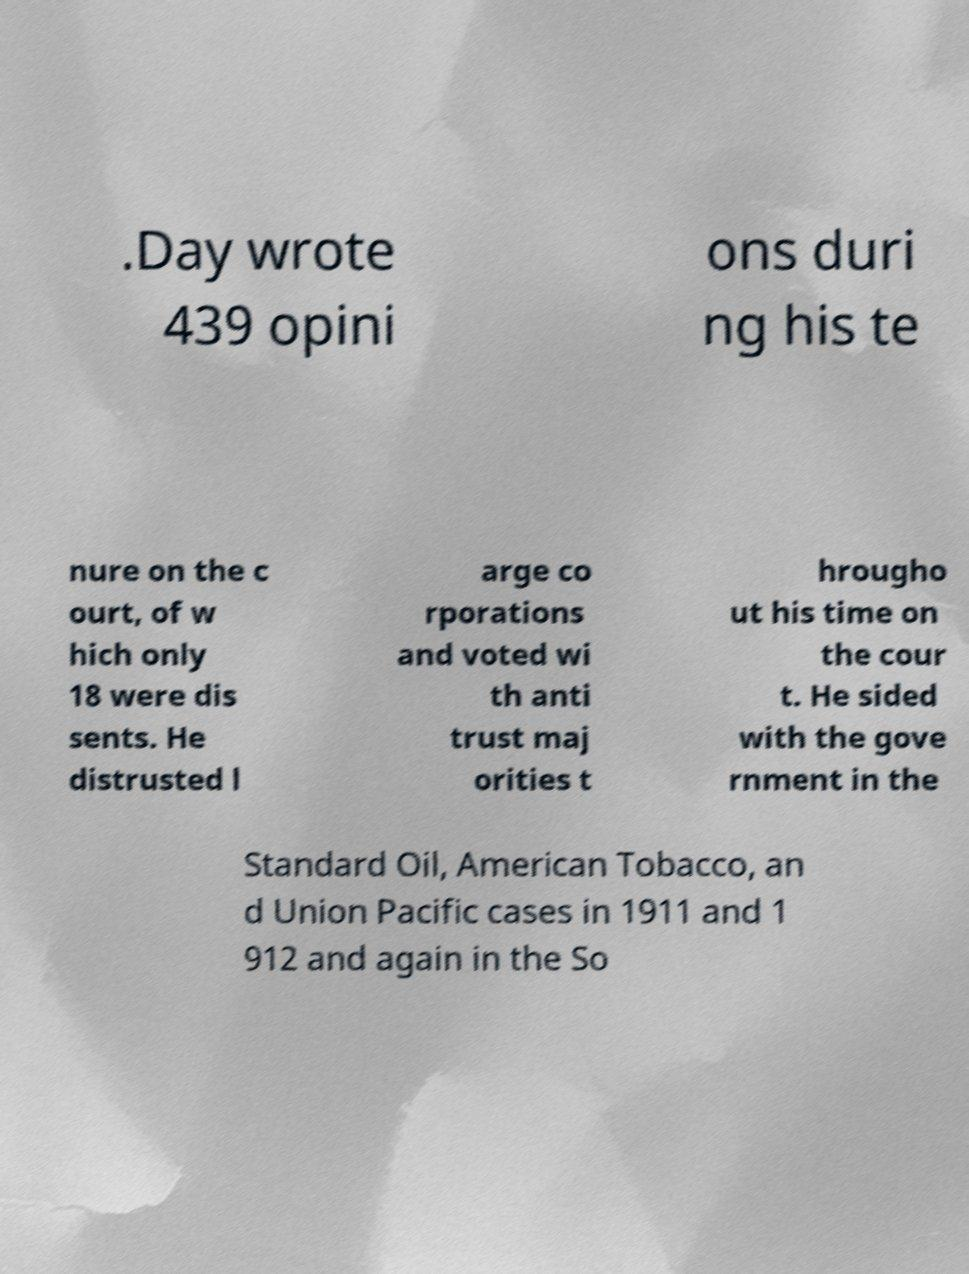Please identify and transcribe the text found in this image. .Day wrote 439 opini ons duri ng his te nure on the c ourt, of w hich only 18 were dis sents. He distrusted l arge co rporations and voted wi th anti trust maj orities t hrougho ut his time on the cour t. He sided with the gove rnment in the Standard Oil, American Tobacco, an d Union Pacific cases in 1911 and 1 912 and again in the So 